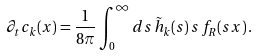<formula> <loc_0><loc_0><loc_500><loc_500>\partial _ { t } c _ { k } ( x ) = \frac { 1 } { 8 \pi } \int _ { 0 } ^ { \infty } d s \, \tilde { h } _ { k } ( s ) \, s \, f _ { R } ( s x ) \, .</formula> 